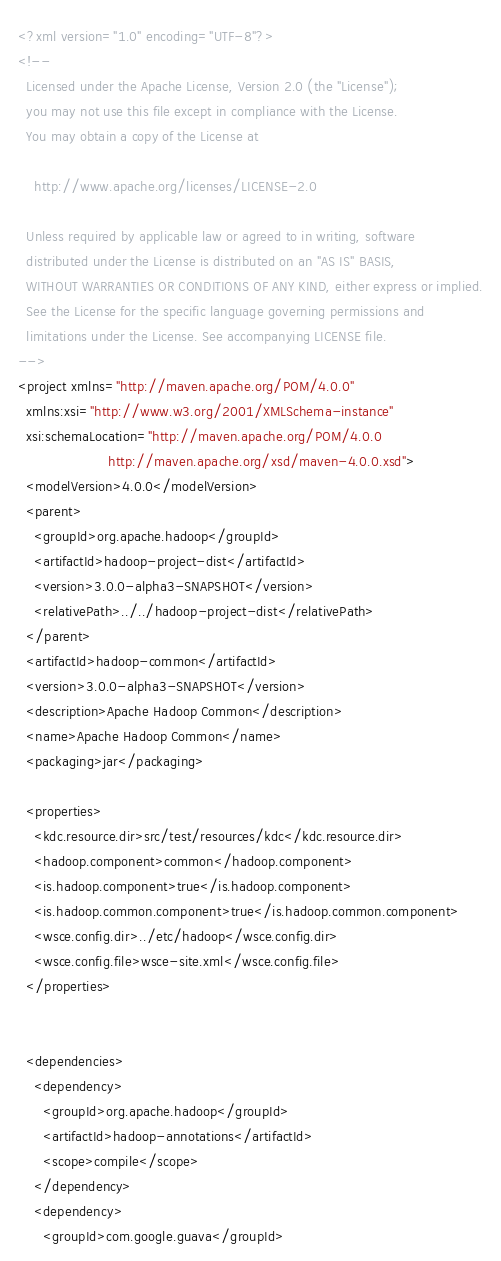<code> <loc_0><loc_0><loc_500><loc_500><_XML_><?xml version="1.0" encoding="UTF-8"?>
<!--
  Licensed under the Apache License, Version 2.0 (the "License");
  you may not use this file except in compliance with the License.
  You may obtain a copy of the License at

    http://www.apache.org/licenses/LICENSE-2.0

  Unless required by applicable law or agreed to in writing, software
  distributed under the License is distributed on an "AS IS" BASIS,
  WITHOUT WARRANTIES OR CONDITIONS OF ANY KIND, either express or implied.
  See the License for the specific language governing permissions and
  limitations under the License. See accompanying LICENSE file.
-->
<project xmlns="http://maven.apache.org/POM/4.0.0"
  xmlns:xsi="http://www.w3.org/2001/XMLSchema-instance"
  xsi:schemaLocation="http://maven.apache.org/POM/4.0.0
                      http://maven.apache.org/xsd/maven-4.0.0.xsd">
  <modelVersion>4.0.0</modelVersion>
  <parent>
    <groupId>org.apache.hadoop</groupId>
    <artifactId>hadoop-project-dist</artifactId>
    <version>3.0.0-alpha3-SNAPSHOT</version>
    <relativePath>../../hadoop-project-dist</relativePath>
  </parent>
  <artifactId>hadoop-common</artifactId>
  <version>3.0.0-alpha3-SNAPSHOT</version>
  <description>Apache Hadoop Common</description>
  <name>Apache Hadoop Common</name>
  <packaging>jar</packaging>

  <properties>
    <kdc.resource.dir>src/test/resources/kdc</kdc.resource.dir>
    <hadoop.component>common</hadoop.component>
    <is.hadoop.component>true</is.hadoop.component>
    <is.hadoop.common.component>true</is.hadoop.common.component>
    <wsce.config.dir>../etc/hadoop</wsce.config.dir>
    <wsce.config.file>wsce-site.xml</wsce.config.file>
  </properties>


  <dependencies>
    <dependency>
      <groupId>org.apache.hadoop</groupId>
      <artifactId>hadoop-annotations</artifactId>
      <scope>compile</scope>
    </dependency>
    <dependency>
      <groupId>com.google.guava</groupId></code> 